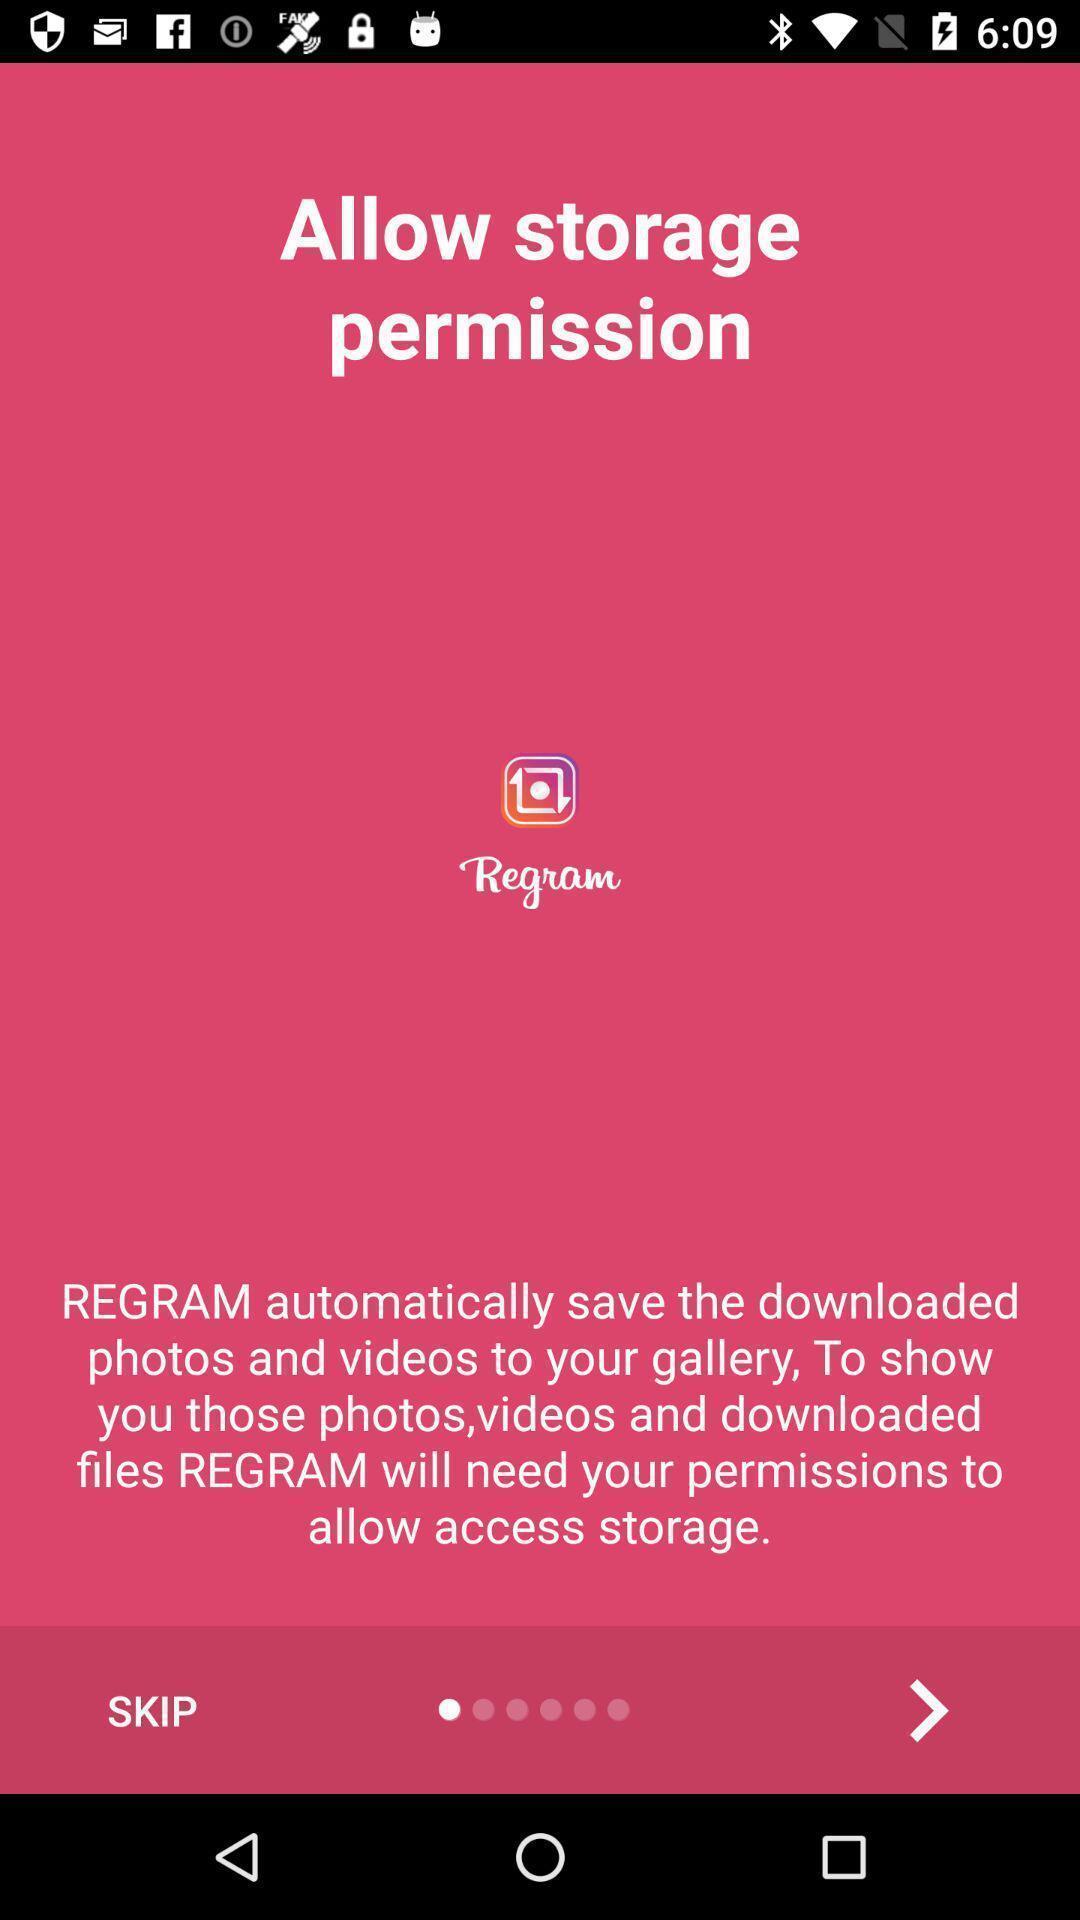What is the overall content of this screenshot? Starting page of the social media application to allow access. 